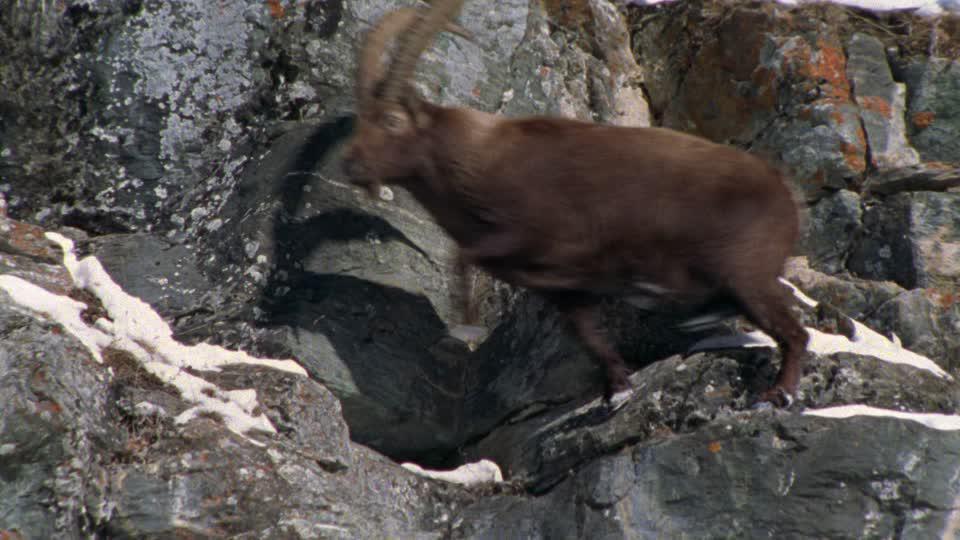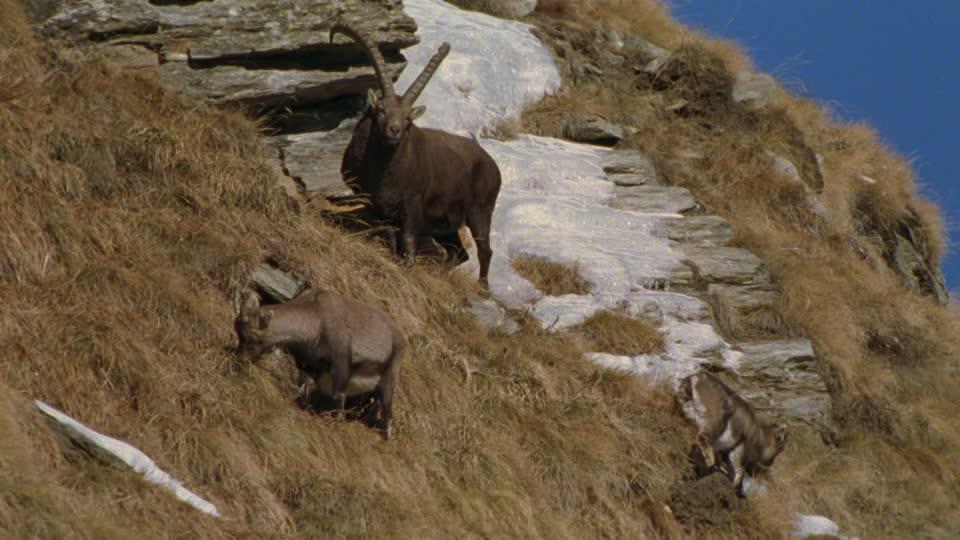The first image is the image on the left, the second image is the image on the right. Examine the images to the left and right. Is the description "There are six mountain goats." accurate? Answer yes or no. No. 